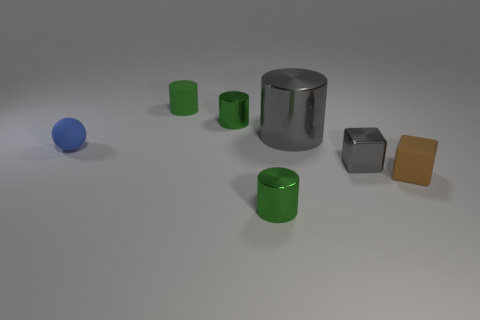Are the blue thing and the big gray object made of the same material?
Give a very brief answer. No. Are there more small gray shiny things that are on the left side of the big gray metallic cylinder than small brown metallic cubes?
Keep it short and to the point. No. What number of objects are tiny green cylinders or small shiny cylinders behind the brown block?
Make the answer very short. 3. Is the number of green metal cylinders that are in front of the gray shiny cylinder greater than the number of tiny brown matte objects on the right side of the rubber sphere?
Ensure brevity in your answer.  No. There is a tiny green cylinder in front of the metallic cylinder to the right of the green metal cylinder in front of the tiny sphere; what is it made of?
Offer a very short reply. Metal. What shape is the blue thing that is the same material as the small brown object?
Your answer should be very brief. Sphere. Are there any objects that are left of the tiny metal cylinder behind the small ball?
Keep it short and to the point. Yes. The brown rubber thing is what size?
Your response must be concise. Small. How many objects are either tiny cyan things or small gray metal blocks?
Your response must be concise. 1. Is the gray object that is in front of the tiny blue matte sphere made of the same material as the green cylinder in front of the brown cube?
Your response must be concise. Yes. 